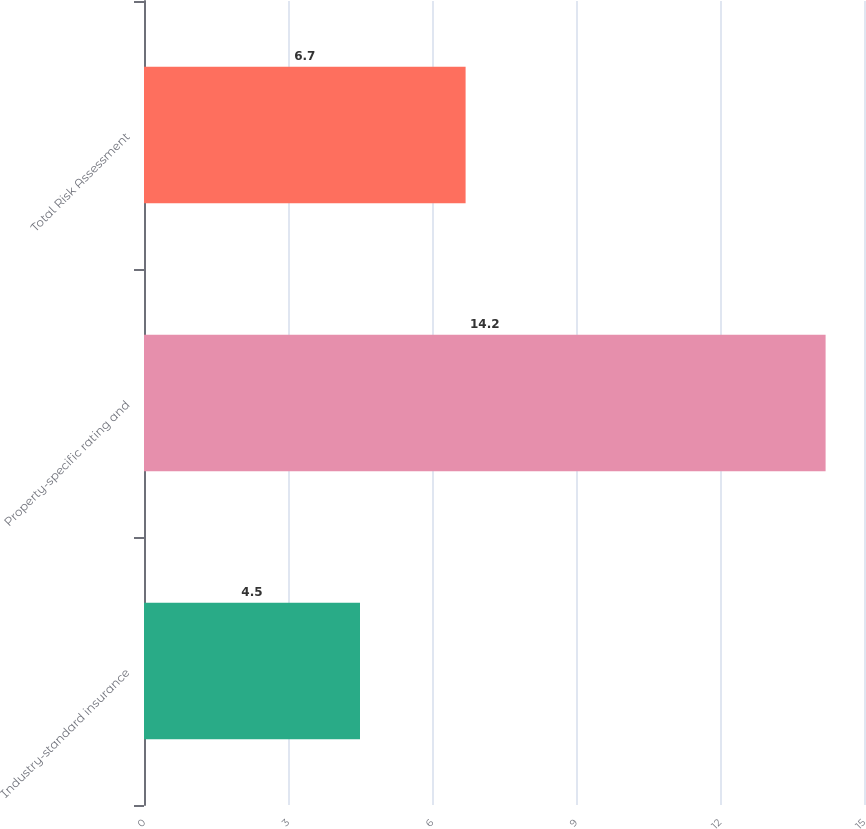Convert chart. <chart><loc_0><loc_0><loc_500><loc_500><bar_chart><fcel>Industry-standard insurance<fcel>Property-specific rating and<fcel>Total Risk Assessment<nl><fcel>4.5<fcel>14.2<fcel>6.7<nl></chart> 